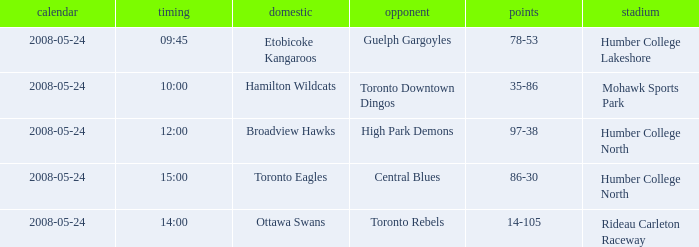Who was the home team of the game at the time of 14:00? Ottawa Swans. 